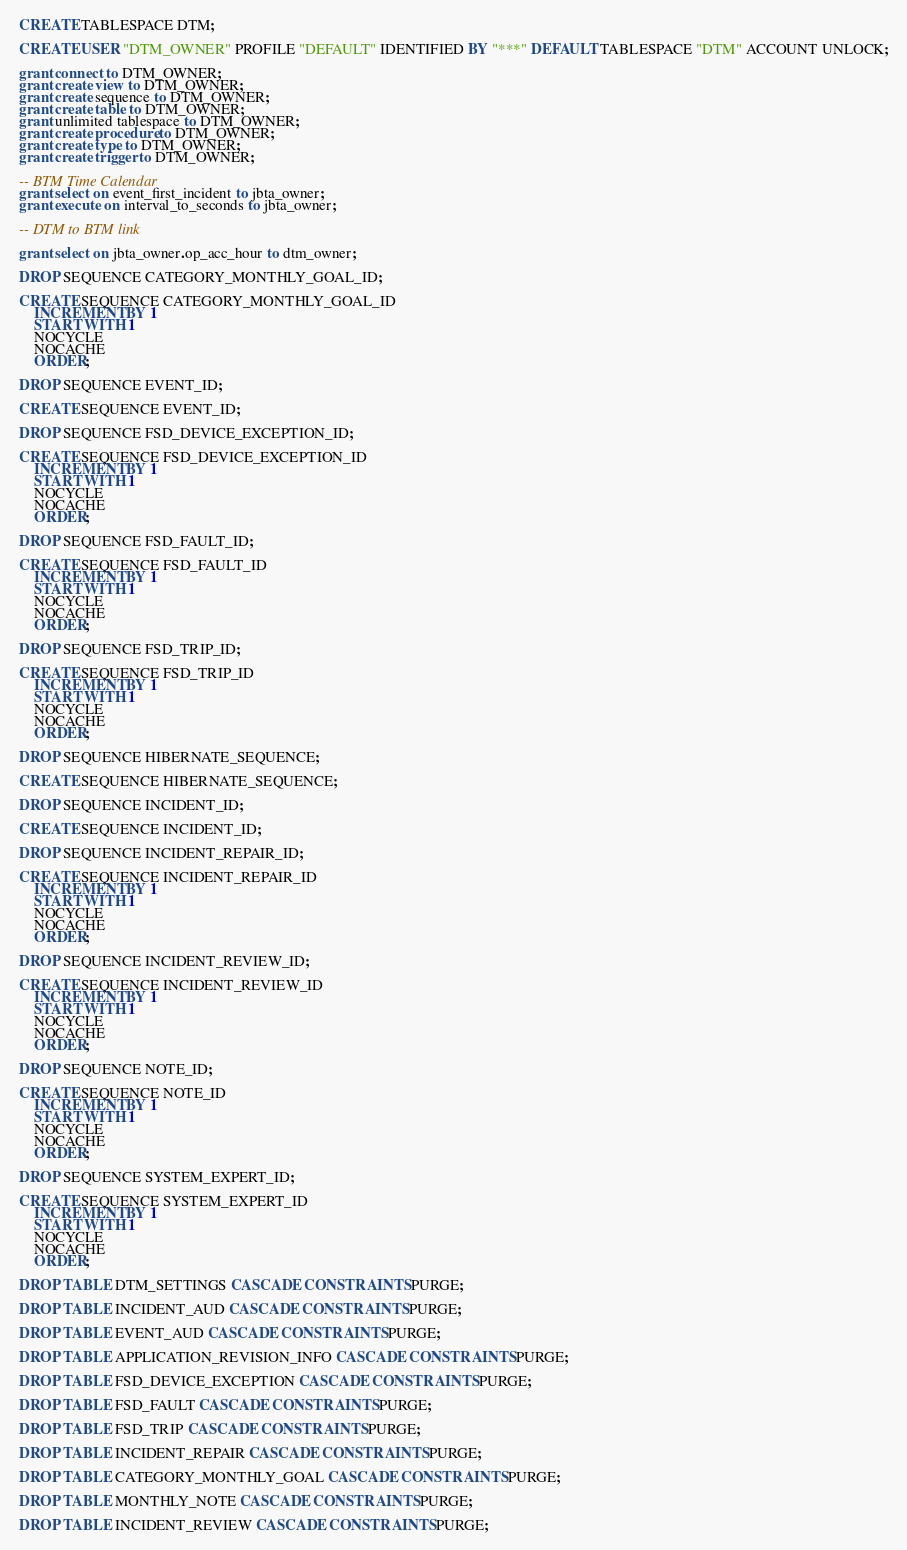Convert code to text. <code><loc_0><loc_0><loc_500><loc_500><_SQL_>
CREATE TABLESPACE DTM;

CREATE USER "DTM_OWNER" PROFILE "DEFAULT" IDENTIFIED BY "***" DEFAULT TABLESPACE "DTM" ACCOUNT UNLOCK;

grant connect to DTM_OWNER;
grant create view to DTM_OWNER;
grant create sequence to DTM_OWNER;
grant create table to DTM_OWNER;
grant unlimited tablespace to DTM_OWNER; 
grant create procedure to DTM_OWNER;
grant create type to DTM_OWNER;
grant create trigger to DTM_OWNER;

-- BTM Time Calendar
grant select on event_first_incident to jbta_owner;
grant execute on interval_to_seconds to jbta_owner;

-- DTM to BTM link

grant select on jbta_owner.op_acc_hour to dtm_owner;

DROP SEQUENCE CATEGORY_MONTHLY_GOAL_ID;

CREATE SEQUENCE CATEGORY_MONTHLY_GOAL_ID
	INCREMENT BY 1
	START WITH 1
	NOCYCLE
	NOCACHE
	ORDER;

DROP SEQUENCE EVENT_ID;

CREATE SEQUENCE EVENT_ID;

DROP SEQUENCE FSD_DEVICE_EXCEPTION_ID;

CREATE SEQUENCE FSD_DEVICE_EXCEPTION_ID
	INCREMENT BY 1
	START WITH 1
	NOCYCLE
	NOCACHE
	ORDER;

DROP SEQUENCE FSD_FAULT_ID;

CREATE SEQUENCE FSD_FAULT_ID
	INCREMENT BY 1
	START WITH 1
	NOCYCLE
	NOCACHE
	ORDER;

DROP SEQUENCE FSD_TRIP_ID;

CREATE SEQUENCE FSD_TRIP_ID
	INCREMENT BY 1
	START WITH 1
	NOCYCLE
	NOCACHE
	ORDER;

DROP SEQUENCE HIBERNATE_SEQUENCE;

CREATE SEQUENCE HIBERNATE_SEQUENCE;

DROP SEQUENCE INCIDENT_ID;

CREATE SEQUENCE INCIDENT_ID;

DROP SEQUENCE INCIDENT_REPAIR_ID;

CREATE SEQUENCE INCIDENT_REPAIR_ID
	INCREMENT BY 1
	START WITH 1
	NOCYCLE
	NOCACHE
	ORDER;

DROP SEQUENCE INCIDENT_REVIEW_ID;

CREATE SEQUENCE INCIDENT_REVIEW_ID
	INCREMENT BY 1
	START WITH 1
	NOCYCLE
	NOCACHE
	ORDER;

DROP SEQUENCE NOTE_ID;

CREATE SEQUENCE NOTE_ID
	INCREMENT BY 1
	START WITH 1
	NOCYCLE
	NOCACHE
	ORDER;

DROP SEQUENCE SYSTEM_EXPERT_ID;

CREATE SEQUENCE SYSTEM_EXPERT_ID
	INCREMENT BY 1
	START WITH 1
	NOCYCLE
	NOCACHE
	ORDER;

DROP TABLE DTM_SETTINGS CASCADE CONSTRAINTS PURGE;

DROP TABLE INCIDENT_AUD CASCADE CONSTRAINTS PURGE;

DROP TABLE EVENT_AUD CASCADE CONSTRAINTS PURGE;

DROP TABLE APPLICATION_REVISION_INFO CASCADE CONSTRAINTS PURGE;

DROP TABLE FSD_DEVICE_EXCEPTION CASCADE CONSTRAINTS PURGE;

DROP TABLE FSD_FAULT CASCADE CONSTRAINTS PURGE;

DROP TABLE FSD_TRIP CASCADE CONSTRAINTS PURGE;

DROP TABLE INCIDENT_REPAIR CASCADE CONSTRAINTS PURGE;

DROP TABLE CATEGORY_MONTHLY_GOAL CASCADE CONSTRAINTS PURGE;

DROP TABLE MONTHLY_NOTE CASCADE CONSTRAINTS PURGE;

DROP TABLE INCIDENT_REVIEW CASCADE CONSTRAINTS PURGE;
</code> 